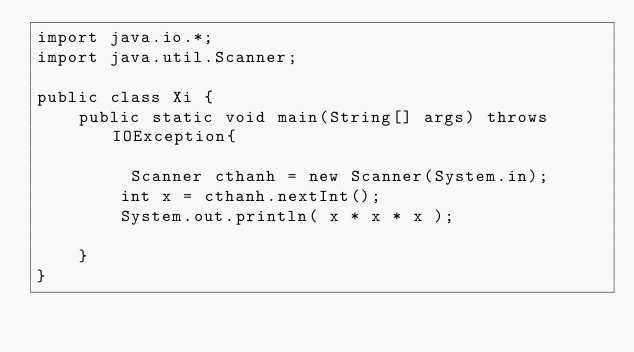<code> <loc_0><loc_0><loc_500><loc_500><_Java_>import java.io.*;
import java.util.Scanner;

public class Xi {
	public static void main(String[] args) throws IOException{	
		
		 Scanner cthanh = new Scanner(System.in);
        int x = cthanh.nextInt();
        System.out.println( x * x * x );
		
	}
}
		
    
    
   
		
    </code> 